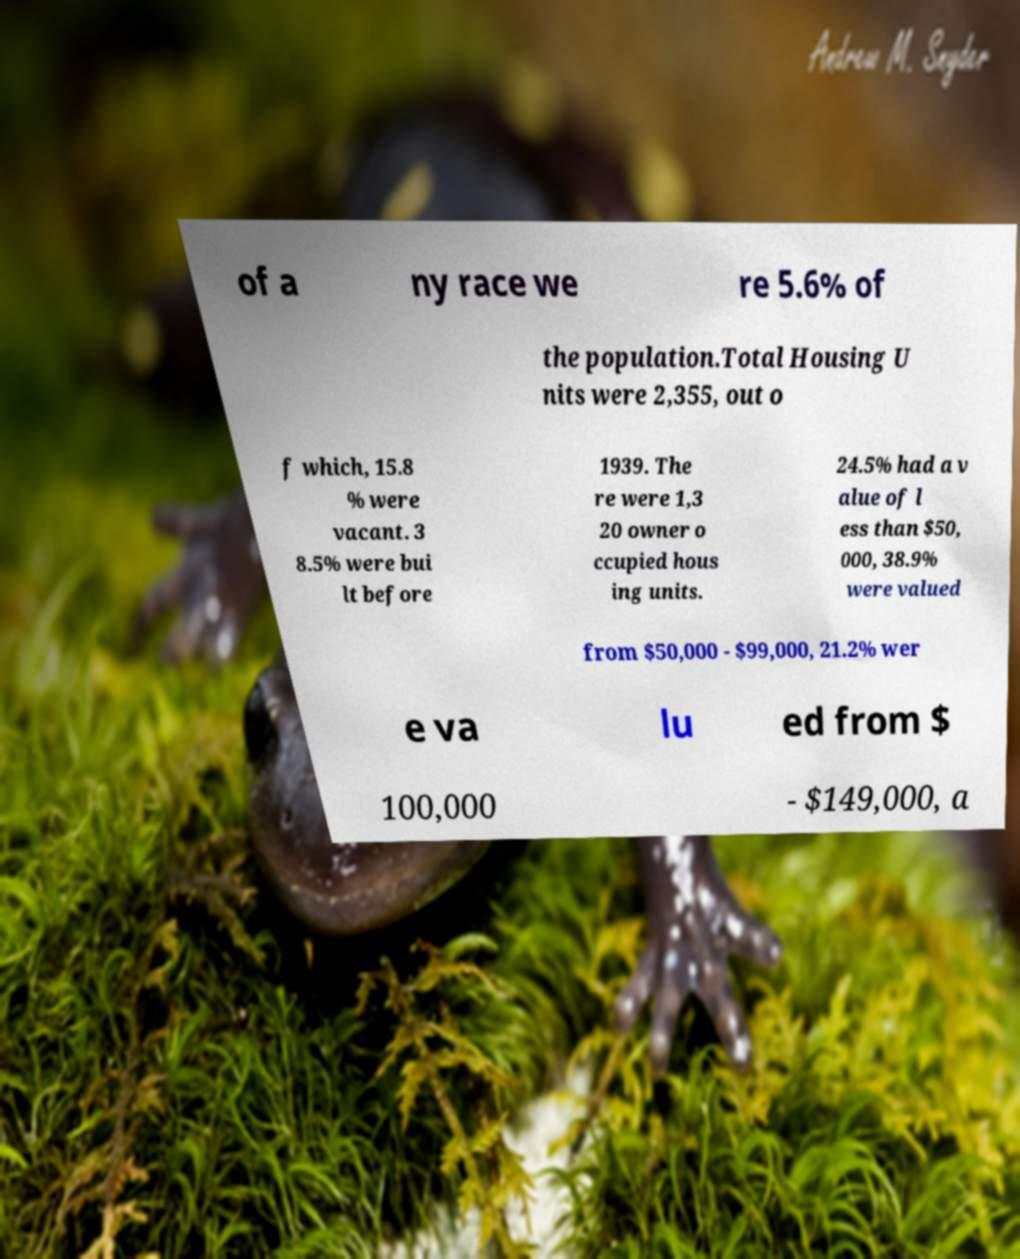There's text embedded in this image that I need extracted. Can you transcribe it verbatim? of a ny race we re 5.6% of the population.Total Housing U nits were 2,355, out o f which, 15.8 % were vacant. 3 8.5% were bui lt before 1939. The re were 1,3 20 owner o ccupied hous ing units. 24.5% had a v alue of l ess than $50, 000, 38.9% were valued from $50,000 - $99,000, 21.2% wer e va lu ed from $ 100,000 - $149,000, a 